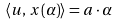Convert formula to latex. <formula><loc_0><loc_0><loc_500><loc_500>\langle { u } , \, { x ( \alpha ) } \rangle = a \cdot \alpha \\</formula> 